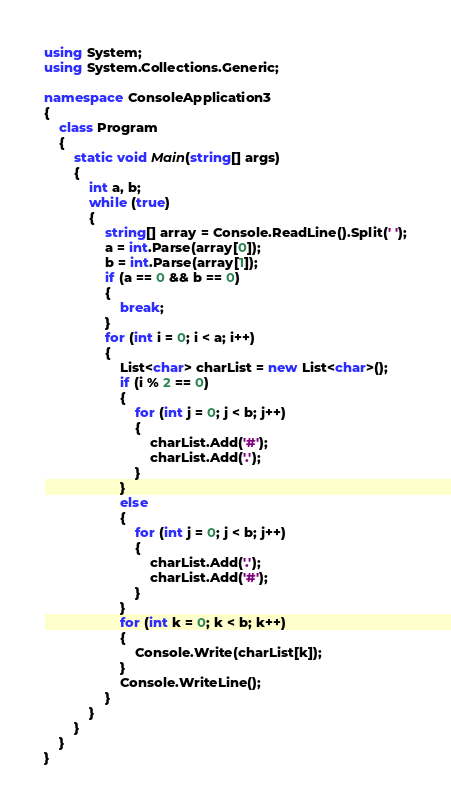<code> <loc_0><loc_0><loc_500><loc_500><_C#_>using System;
using System.Collections.Generic;

namespace ConsoleApplication3
{
    class Program
    {
        static void Main(string[] args)
        {
            int a, b;
            while (true)
            {
                string[] array = Console.ReadLine().Split(' ');
                a = int.Parse(array[0]);
                b = int.Parse(array[1]);
                if (a == 0 && b == 0)
                {
                    break;
                }
                for (int i = 0; i < a; i++)
                {
                    List<char> charList = new List<char>();
                    if (i % 2 == 0)
                    {
                        for (int j = 0; j < b; j++)
                        {
                            charList.Add('#');
                            charList.Add('.');
                        }
                    }
                    else
                    {
                        for (int j = 0; j < b; j++)
                        {
                            charList.Add('.');
                            charList.Add('#');
                        }
                    }
                    for (int k = 0; k < b; k++)
                    {
                        Console.Write(charList[k]);
                    }
                    Console.WriteLine();
                }
            }
        }
    }
}</code> 